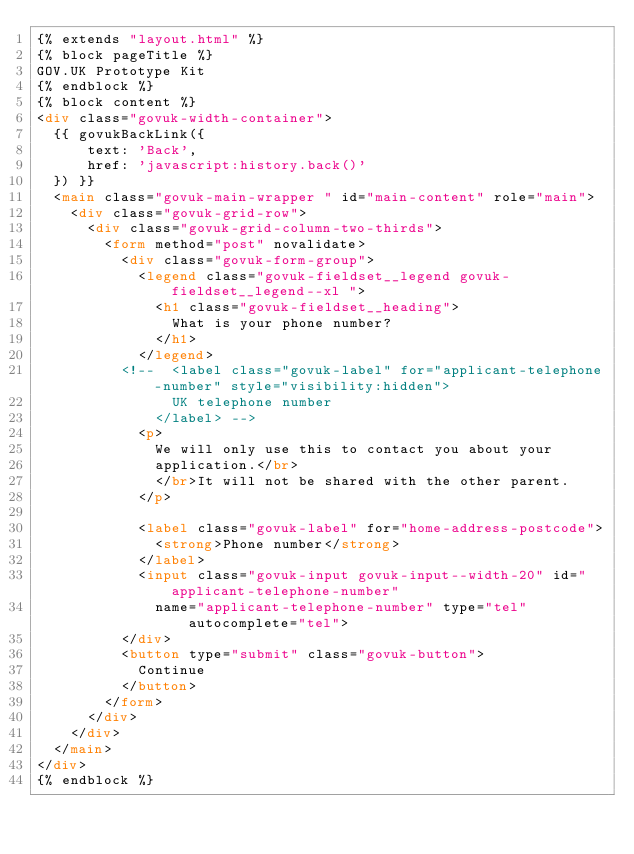Convert code to text. <code><loc_0><loc_0><loc_500><loc_500><_HTML_>{% extends "layout.html" %}
{% block pageTitle %}
GOV.UK Prototype Kit
{% endblock %}
{% block content %}
<div class="govuk-width-container">
  {{ govukBackLink({
      text: 'Back',
      href: 'javascript:history.back()'
  }) }}
  <main class="govuk-main-wrapper " id="main-content" role="main">
    <div class="govuk-grid-row">
      <div class="govuk-grid-column-two-thirds">
        <form method="post" novalidate>
          <div class="govuk-form-group">
            <legend class="govuk-fieldset__legend govuk-fieldset__legend--xl ">
              <h1 class="govuk-fieldset__heading">
                What is your phone number?
              </h1>
            </legend>
          <!--  <label class="govuk-label" for="applicant-telephone-number" style="visibility:hidden">
                UK telephone number
              </label> -->
            <p>
              We will only use this to contact you about your
              application.</br>
              </br>It will not be shared with the other parent.
            </p>

            <label class="govuk-label" for="home-address-postcode">
              <strong>Phone number</strong>
            </label>
            <input class="govuk-input govuk-input--width-20" id="applicant-telephone-number"
              name="applicant-telephone-number" type="tel" autocomplete="tel">
          </div>
          <button type="submit" class="govuk-button">
            Continue
          </button>
        </form>
      </div>
    </div>
  </main>
</div>
{% endblock %}
</code> 